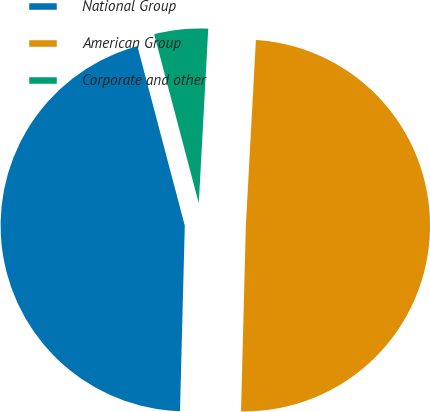Convert chart. <chart><loc_0><loc_0><loc_500><loc_500><pie_chart><fcel>National Group<fcel>American Group<fcel>Corporate and other<nl><fcel>45.48%<fcel>49.55%<fcel>4.97%<nl></chart> 